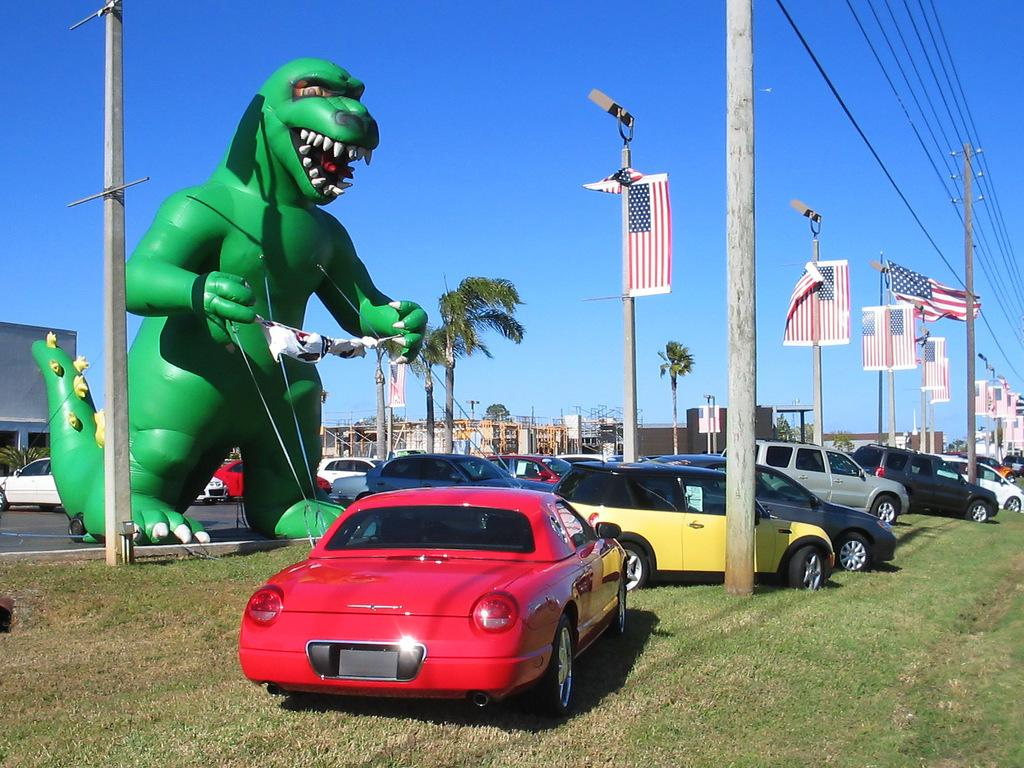What can be seen in the foreground of the image? In the foreground of the image, there are vehicles and poles. What is visible in the middle of the image? The middle of the image contains a dragon image and trees. What is visible at the top of the image? The sky is visible at the top of the image. What types of objects are present in the image? Vehicles, poles, flags, and buildings are visible in the image. What type of breakfast is being served in the image? There is no breakfast present in the image. Can you describe the man in the image? There is no man present in the image. 